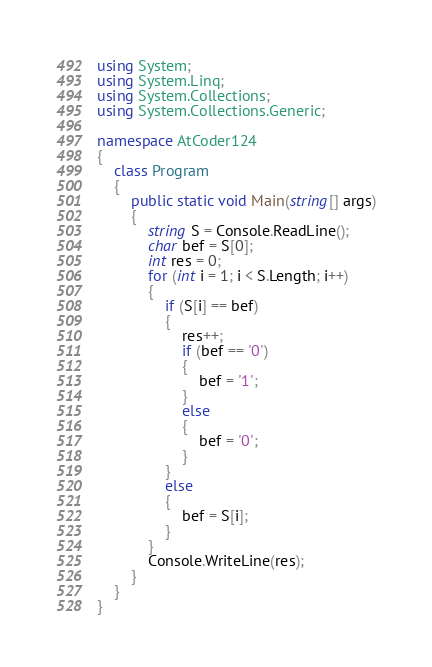<code> <loc_0><loc_0><loc_500><loc_500><_C#_>using System;
using System.Linq;
using System.Collections;
using System.Collections.Generic;

namespace AtCoder124
{
    class Program
    {
        public static void Main(string[] args)
        {
            string S = Console.ReadLine();
            char bef = S[0];
            int res = 0;
            for (int i = 1; i < S.Length; i++)
            {
                if (S[i] == bef)
                {
                    res++;
                    if (bef == '0')
                    {
                        bef = '1';
                    }
                    else
                    {
                        bef = '0';
                    }
                }
                else
                {
                    bef = S[i];
                }
            }
            Console.WriteLine(res);
        }
    }
}</code> 